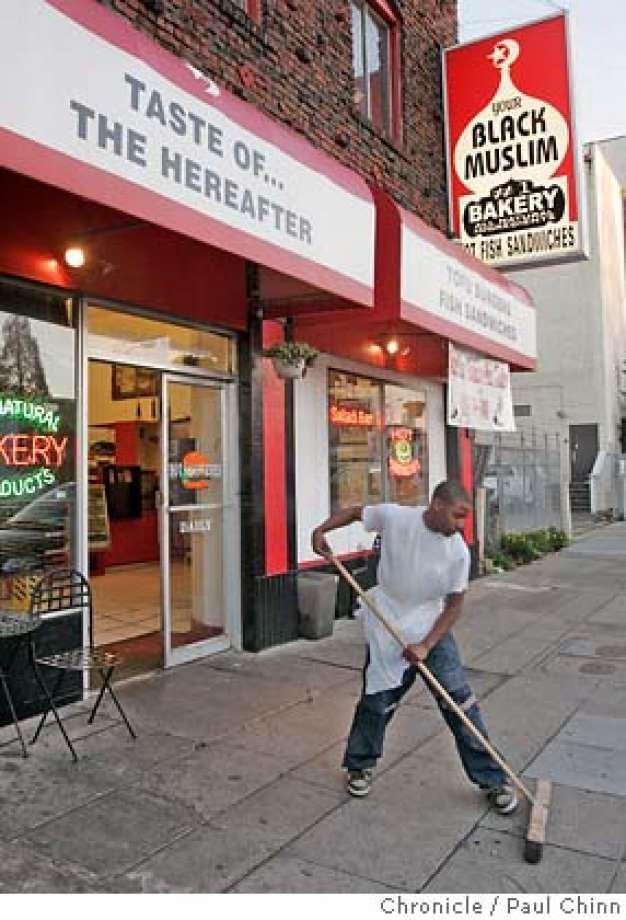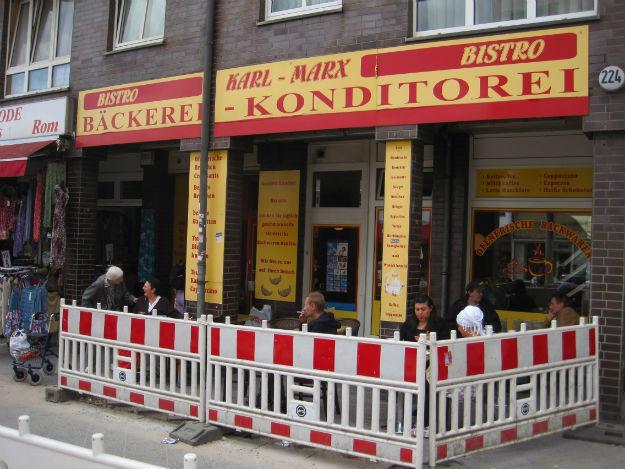The first image is the image on the left, the second image is the image on the right. Analyze the images presented: Is the assertion "The building in one of the images has a blue awning." valid? Answer yes or no. No. The first image is the image on the left, the second image is the image on the right. Assess this claim about the two images: "there is a brick building with a blue fabric awning, above the awning is a white painted window". Correct or not? Answer yes or no. No. 